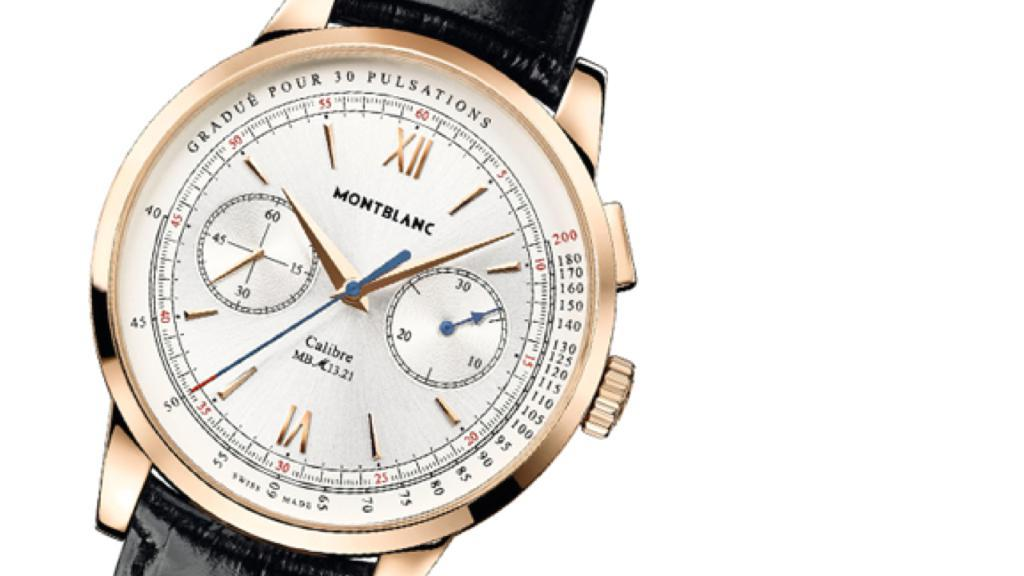<image>
Create a compact narrative representing the image presented. A black and gold wristwatch from Montblanc watch co 